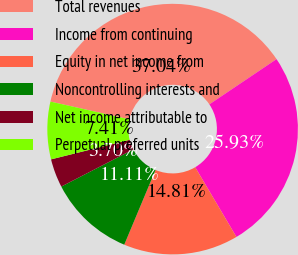<chart> <loc_0><loc_0><loc_500><loc_500><pie_chart><fcel>Total revenues<fcel>Income from continuing<fcel>Equity in net income from<fcel>Noncontrolling interests and<fcel>Net income attributable to<fcel>Perpetual preferred units<nl><fcel>37.04%<fcel>25.93%<fcel>14.81%<fcel>11.11%<fcel>3.7%<fcel>7.41%<nl></chart> 